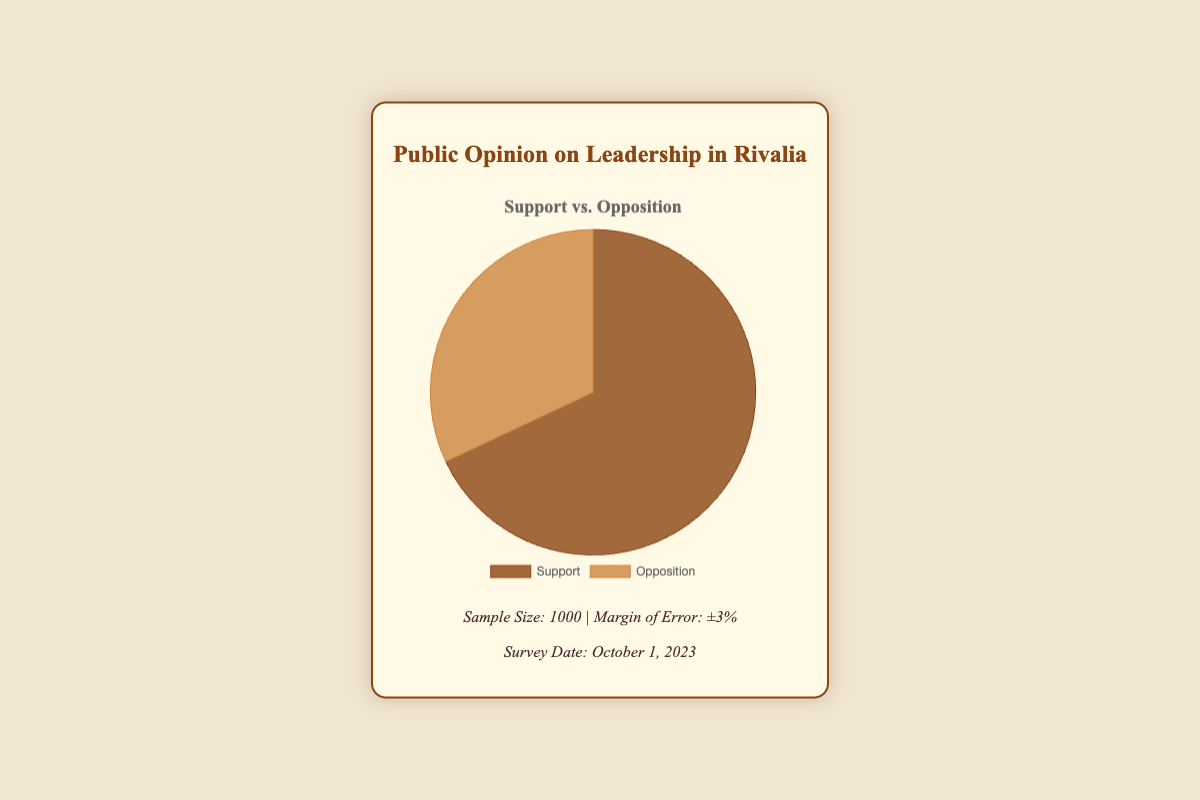What is the percentage of people who support the leadership? The pie chart shows two segments, Support and Opposition. The Support segment is labeled with its value, which is 68%.
Answer: 68% What is the percentage of people who oppose the leadership? The pie chart includes a segment labeled Opposition, which is 32%.
Answer: 32% Is the percentage of support greater than the percentage of opposition? By comparing the two segments, the Support segment (68%) is greater than the Opposition segment (32%).
Answer: Yes What is the total combined percentage for support and opposition? The pie chart shows two percentages, 68% (Support) and 32% (Opposition). Summing these values gives 68% + 32% = 100%.
Answer: 100% What is the difference in percentage points between support and opposition? The support percentage is 68% and the opposition percentage is 32%. Subtracting these gives 68% - 32% = 36%.
Answer: 36% Which segment has the darker shade of brown? The pie chart visually represents Support with a darker shade of brown compared to Opposition.
Answer: Support Are the labels placed at the bottom of the chart legend? The chart's legend positions the labels for Support and Opposition at the bottom of the chart.
Answer: Yes How does the support percentage compare to the margin of error? The chart shows a margin of error of ±3%. The support percentage is 68%, which is significantly higher than this margin.
Answer: Significantly higher Which data point corresponds to the lighter color in the pie chart? Opposition is represented with a lighter shade of brown in the pie chart.
Answer: Opposition If the margin of error is ±3%, what is the possible range for the support percentage? With a 68% support and ±3% margin of error, the support percentage varies from (68-3)% to (68+3)%, which is 65% to 71%.
Answer: 65% to 71% 